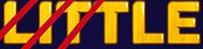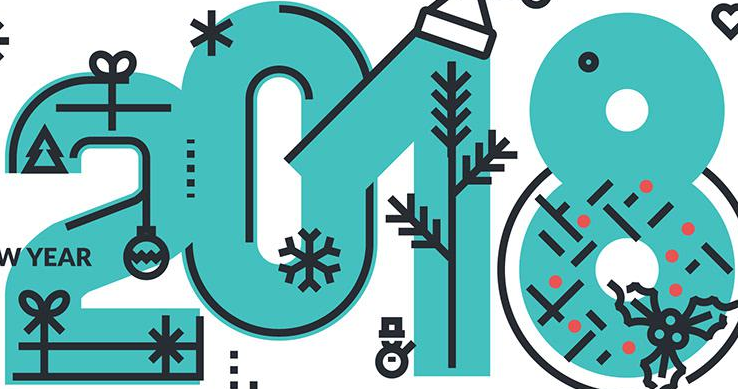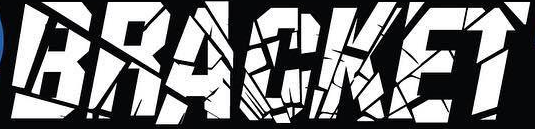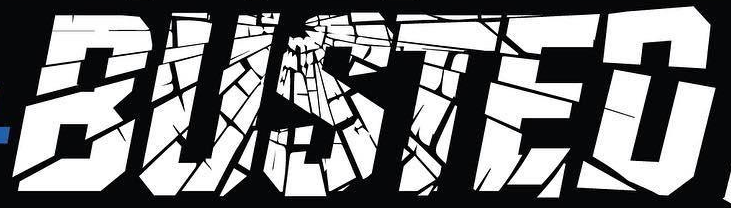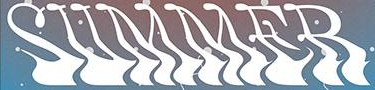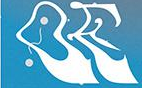What text appears in these images from left to right, separated by a semicolon? LITTLE; 2018; BRACKET; BUSTED; SUMMER; OE 